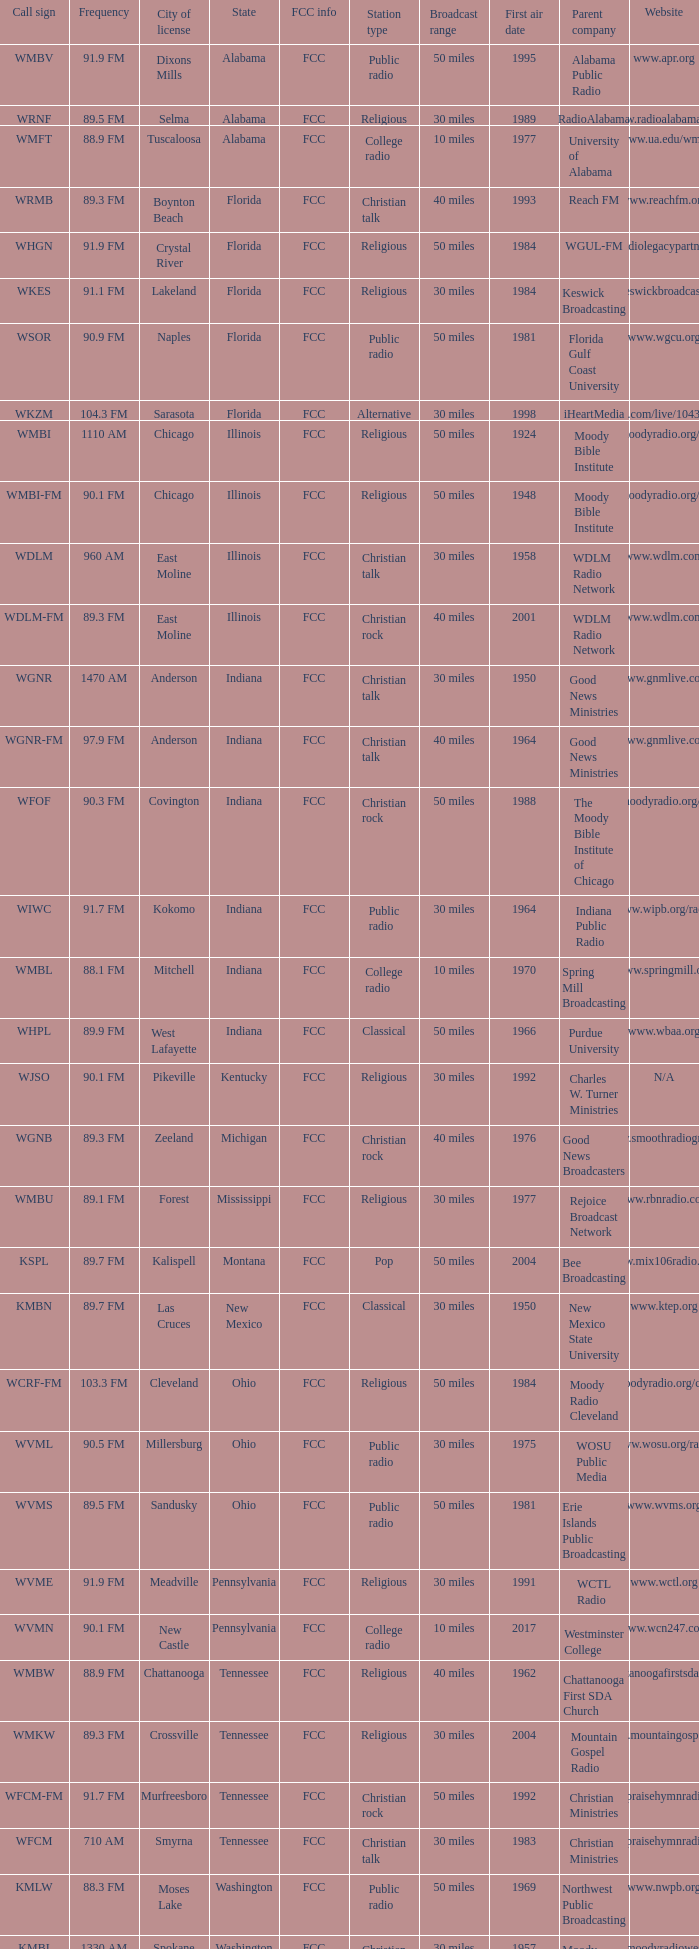3 fm permitted? Cleveland. 